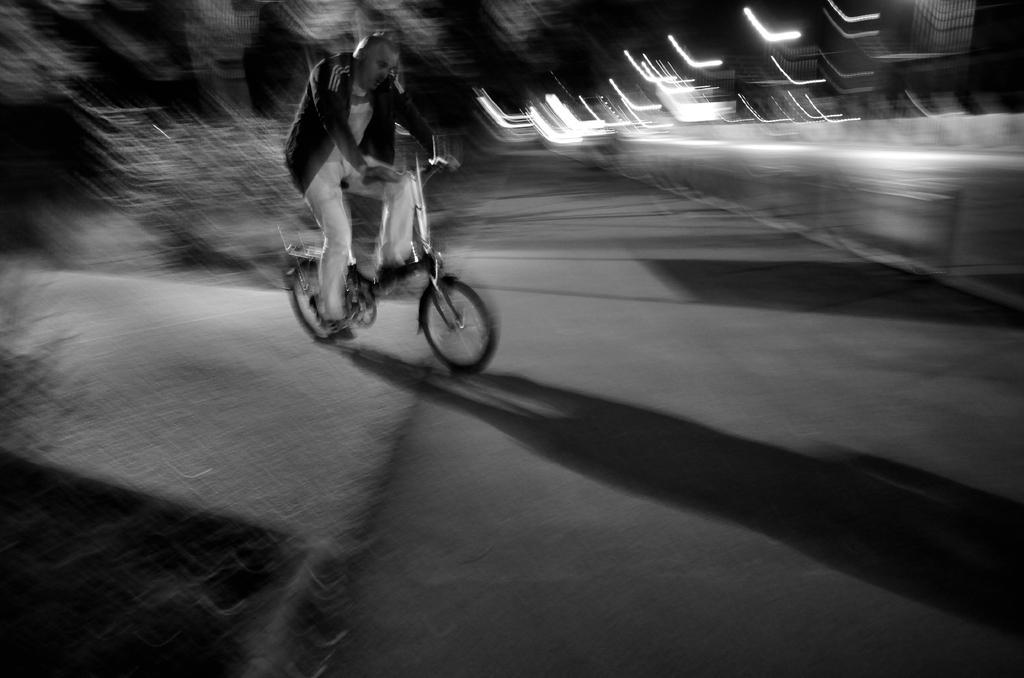In one or two sentences, can you explain what this image depicts? Here we can see a person riding a bicycle on the road 